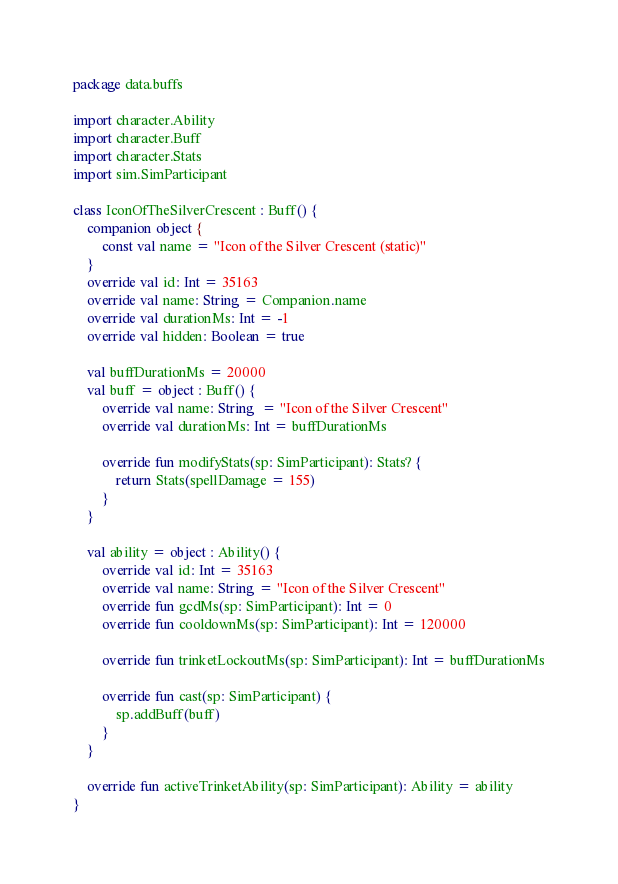<code> <loc_0><loc_0><loc_500><loc_500><_Kotlin_>package data.buffs

import character.Ability
import character.Buff
import character.Stats
import sim.SimParticipant

class IconOfTheSilverCrescent : Buff() {
    companion object {
        const val name = "Icon of the Silver Crescent (static)"
    }
    override val id: Int = 35163
    override val name: String = Companion.name
    override val durationMs: Int = -1
    override val hidden: Boolean = true

    val buffDurationMs = 20000
    val buff = object : Buff() {
        override val name: String  = "Icon of the Silver Crescent"
        override val durationMs: Int = buffDurationMs

        override fun modifyStats(sp: SimParticipant): Stats? {
            return Stats(spellDamage = 155)
        }
    }

    val ability = object : Ability() {
        override val id: Int = 35163
        override val name: String = "Icon of the Silver Crescent"
        override fun gcdMs(sp: SimParticipant): Int = 0
        override fun cooldownMs(sp: SimParticipant): Int = 120000

        override fun trinketLockoutMs(sp: SimParticipant): Int = buffDurationMs

        override fun cast(sp: SimParticipant) {
            sp.addBuff(buff)
        }
    }

    override fun activeTrinketAbility(sp: SimParticipant): Ability = ability
}
</code> 